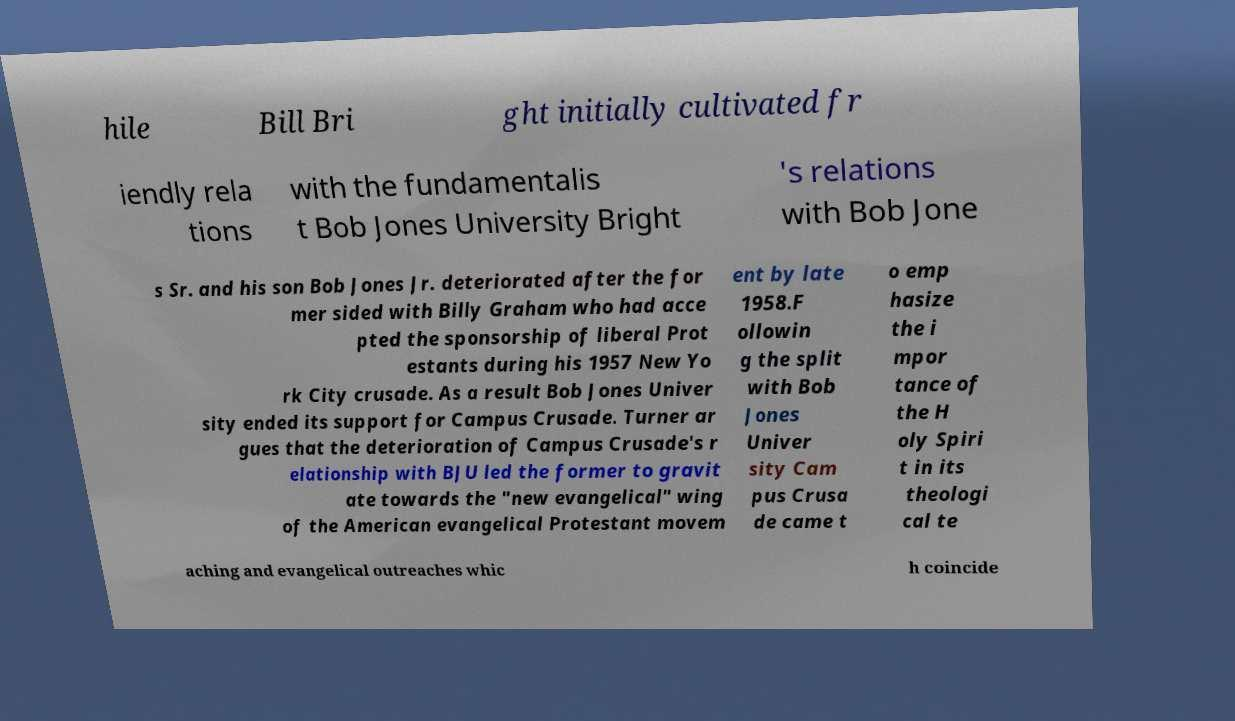There's text embedded in this image that I need extracted. Can you transcribe it verbatim? hile Bill Bri ght initially cultivated fr iendly rela tions with the fundamentalis t Bob Jones University Bright 's relations with Bob Jone s Sr. and his son Bob Jones Jr. deteriorated after the for mer sided with Billy Graham who had acce pted the sponsorship of liberal Prot estants during his 1957 New Yo rk City crusade. As a result Bob Jones Univer sity ended its support for Campus Crusade. Turner ar gues that the deterioration of Campus Crusade's r elationship with BJU led the former to gravit ate towards the "new evangelical" wing of the American evangelical Protestant movem ent by late 1958.F ollowin g the split with Bob Jones Univer sity Cam pus Crusa de came t o emp hasize the i mpor tance of the H oly Spiri t in its theologi cal te aching and evangelical outreaches whic h coincide 